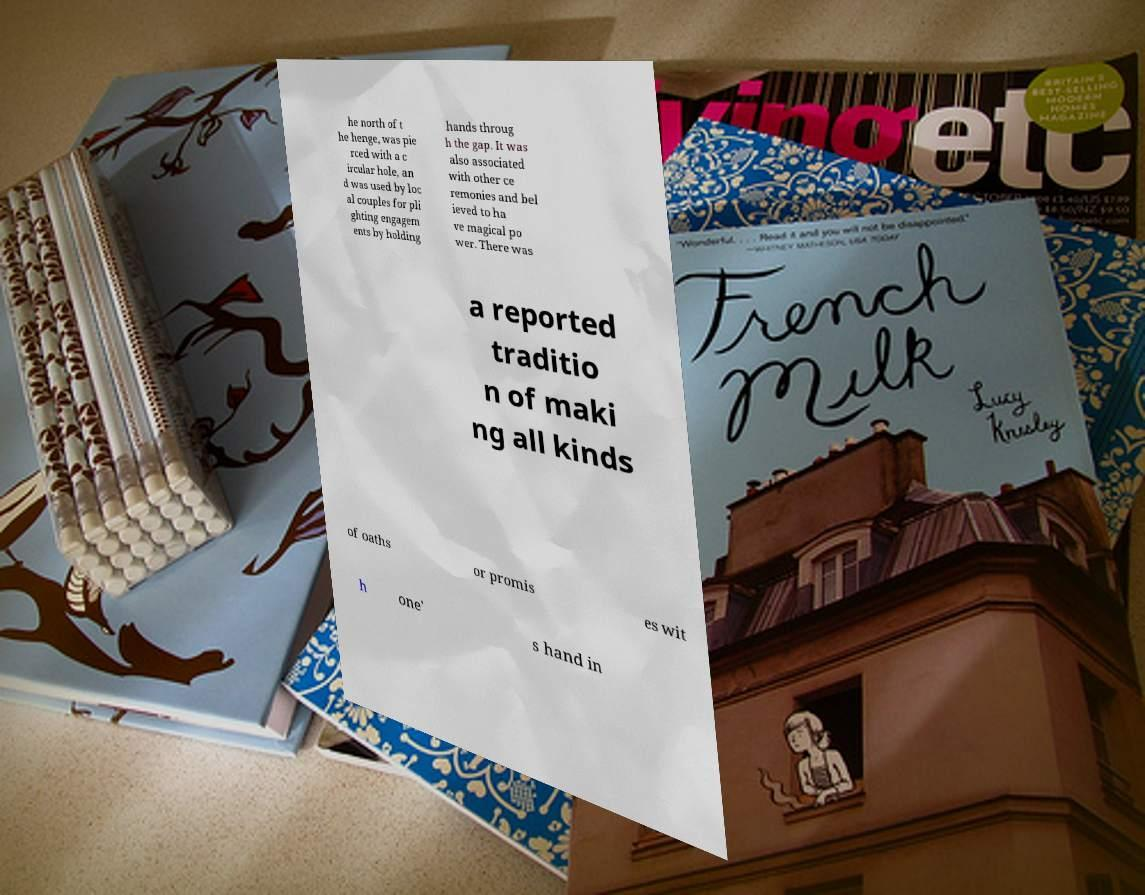Can you accurately transcribe the text from the provided image for me? he north of t he henge, was pie rced with a c ircular hole, an d was used by loc al couples for pli ghting engagem ents by holding hands throug h the gap. It was also associated with other ce remonies and bel ieved to ha ve magical po wer. There was a reported traditio n of maki ng all kinds of oaths or promis es wit h one' s hand in 